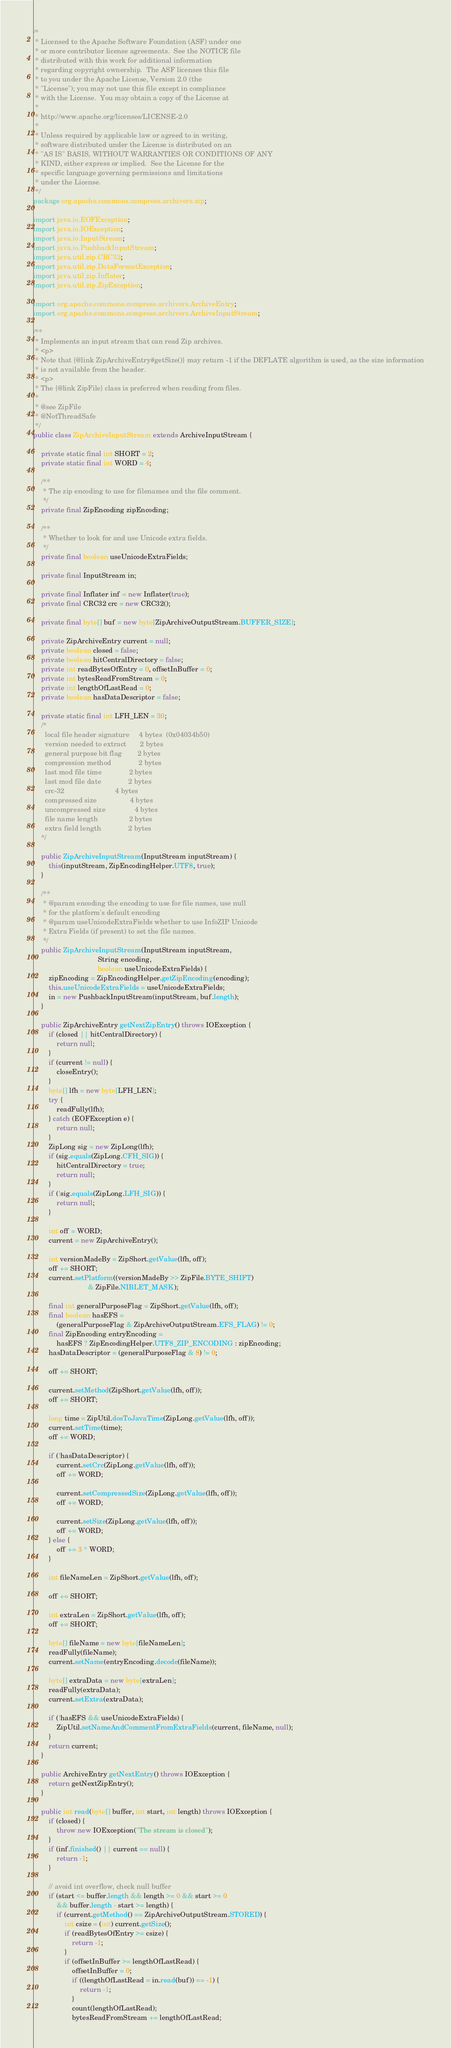<code> <loc_0><loc_0><loc_500><loc_500><_Java_>/*
 * Licensed to the Apache Software Foundation (ASF) under one
 * or more contributor license agreements.  See the NOTICE file
 * distributed with this work for additional information
 * regarding copyright ownership.  The ASF licenses this file
 * to you under the Apache License, Version 2.0 (the
 * "License"); you may not use this file except in compliance
 * with the License.  You may obtain a copy of the License at
 *
 * http://www.apache.org/licenses/LICENSE-2.0
 *
 * Unless required by applicable law or agreed to in writing,
 * software distributed under the License is distributed on an
 * "AS IS" BASIS, WITHOUT WARRANTIES OR CONDITIONS OF ANY
 * KIND, either express or implied.  See the License for the
 * specific language governing permissions and limitations
 * under the License.
 */
package org.apache.commons.compress.archivers.zip;

import java.io.EOFException;
import java.io.IOException;
import java.io.InputStream;
import java.io.PushbackInputStream;
import java.util.zip.CRC32;
import java.util.zip.DataFormatException;
import java.util.zip.Inflater;
import java.util.zip.ZipException;

import org.apache.commons.compress.archivers.ArchiveEntry;
import org.apache.commons.compress.archivers.ArchiveInputStream;

/**
 * Implements an input stream that can read Zip archives.
 * <p>
 * Note that {@link ZipArchiveEntry#getSize()} may return -1 if the DEFLATE algorithm is used, as the size information
 * is not available from the header.
 * <p>
 * The {@link ZipFile} class is preferred when reading from files.
 *  
 * @see ZipFile
 * @NotThreadSafe
 */
public class ZipArchiveInputStream extends ArchiveInputStream {

    private static final int SHORT = 2;
    private static final int WORD = 4;

    /**
     * The zip encoding to use for filenames and the file comment.
     */
    private final ZipEncoding zipEncoding;

    /**
     * Whether to look for and use Unicode extra fields.
     */
    private final boolean useUnicodeExtraFields;

    private final InputStream in;

    private final Inflater inf = new Inflater(true);
    private final CRC32 crc = new CRC32();

    private final byte[] buf = new byte[ZipArchiveOutputStream.BUFFER_SIZE];

    private ZipArchiveEntry current = null;
    private boolean closed = false;
    private boolean hitCentralDirectory = false;
    private int readBytesOfEntry = 0, offsetInBuffer = 0;
    private int bytesReadFromStream = 0;
    private int lengthOfLastRead = 0;
    private boolean hasDataDescriptor = false;

    private static final int LFH_LEN = 30;
    /*
      local file header signature     4 bytes  (0x04034b50)
      version needed to extract       2 bytes
      general purpose bit flag        2 bytes
      compression method              2 bytes
      last mod file time              2 bytes
      last mod file date              2 bytes
      crc-32                          4 bytes
      compressed size                 4 bytes
      uncompressed size               4 bytes
      file name length                2 bytes
      extra field length              2 bytes
    */

    public ZipArchiveInputStream(InputStream inputStream) {
        this(inputStream, ZipEncodingHelper.UTF8, true);
    }

    /**
     * @param encoding the encoding to use for file names, use null
     * for the platform's default encoding
     * @param useUnicodeExtraFields whether to use InfoZIP Unicode
     * Extra Fields (if present) to set the file names.
     */
    public ZipArchiveInputStream(InputStream inputStream,
                                 String encoding,
                                 boolean useUnicodeExtraFields) {
        zipEncoding = ZipEncodingHelper.getZipEncoding(encoding);
        this.useUnicodeExtraFields = useUnicodeExtraFields;
        in = new PushbackInputStream(inputStream, buf.length);
    }

    public ZipArchiveEntry getNextZipEntry() throws IOException {
        if (closed || hitCentralDirectory) {
            return null;
        }
        if (current != null) {
            closeEntry();
        }
        byte[] lfh = new byte[LFH_LEN];
        try {
            readFully(lfh);
        } catch (EOFException e) {
            return null;
        }
        ZipLong sig = new ZipLong(lfh);
        if (sig.equals(ZipLong.CFH_SIG)) {
            hitCentralDirectory = true;
            return null;
        }
        if (!sig.equals(ZipLong.LFH_SIG)) {
            return null;
        }

        int off = WORD;
        current = new ZipArchiveEntry();

        int versionMadeBy = ZipShort.getValue(lfh, off);
        off += SHORT;
        current.setPlatform((versionMadeBy >> ZipFile.BYTE_SHIFT)
                            & ZipFile.NIBLET_MASK);

        final int generalPurposeFlag = ZipShort.getValue(lfh, off);
        final boolean hasEFS = 
            (generalPurposeFlag & ZipArchiveOutputStream.EFS_FLAG) != 0;
        final ZipEncoding entryEncoding =
            hasEFS ? ZipEncodingHelper.UTF8_ZIP_ENCODING : zipEncoding;
        hasDataDescriptor = (generalPurposeFlag & 8) != 0;

        off += SHORT;

        current.setMethod(ZipShort.getValue(lfh, off));
        off += SHORT;

        long time = ZipUtil.dosToJavaTime(ZipLong.getValue(lfh, off));
        current.setTime(time);
        off += WORD;

        if (!hasDataDescriptor) {
            current.setCrc(ZipLong.getValue(lfh, off));
            off += WORD;

            current.setCompressedSize(ZipLong.getValue(lfh, off));
            off += WORD;

            current.setSize(ZipLong.getValue(lfh, off));
            off += WORD;
        } else {
            off += 3 * WORD;
        }

        int fileNameLen = ZipShort.getValue(lfh, off);

        off += SHORT;

        int extraLen = ZipShort.getValue(lfh, off);
        off += SHORT;

        byte[] fileName = new byte[fileNameLen];
        readFully(fileName);
        current.setName(entryEncoding.decode(fileName));

        byte[] extraData = new byte[extraLen];
        readFully(extraData);
        current.setExtra(extraData);

        if (!hasEFS && useUnicodeExtraFields) {
            ZipUtil.setNameAndCommentFromExtraFields(current, fileName, null);
        }
        return current;
    }

    public ArchiveEntry getNextEntry() throws IOException {
        return getNextZipEntry();
    }

    public int read(byte[] buffer, int start, int length) throws IOException {
        if (closed) {
            throw new IOException("The stream is closed");
        }
        if (inf.finished() || current == null) {
            return -1;
        }

        // avoid int overflow, check null buffer
        if (start <= buffer.length && length >= 0 && start >= 0
            && buffer.length - start >= length) {
            if (current.getMethod() == ZipArchiveOutputStream.STORED) {
                int csize = (int) current.getSize();
                if (readBytesOfEntry >= csize) {
                    return -1;
                }
                if (offsetInBuffer >= lengthOfLastRead) {
                    offsetInBuffer = 0;
                    if ((lengthOfLastRead = in.read(buf)) == -1) {
                        return -1;
                    }
                    count(lengthOfLastRead);
                    bytesReadFromStream += lengthOfLastRead;</code> 